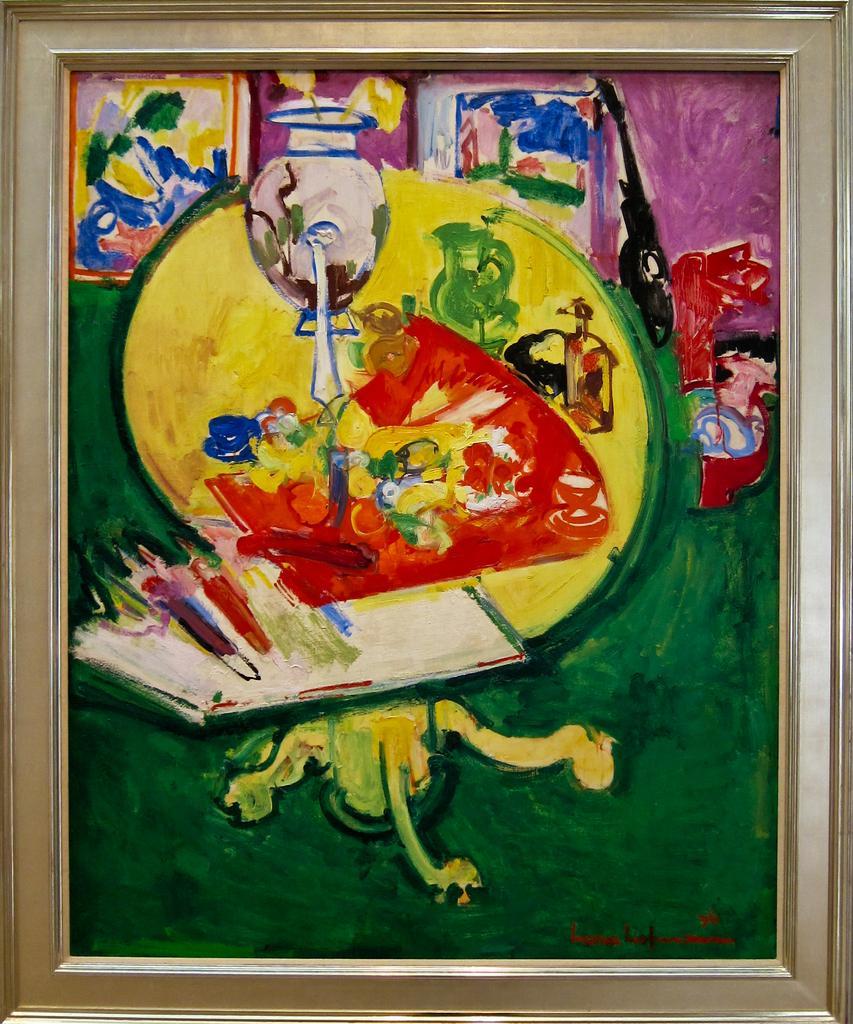In one or two sentences, can you explain what this image depicts? The picture consists of a painting. 